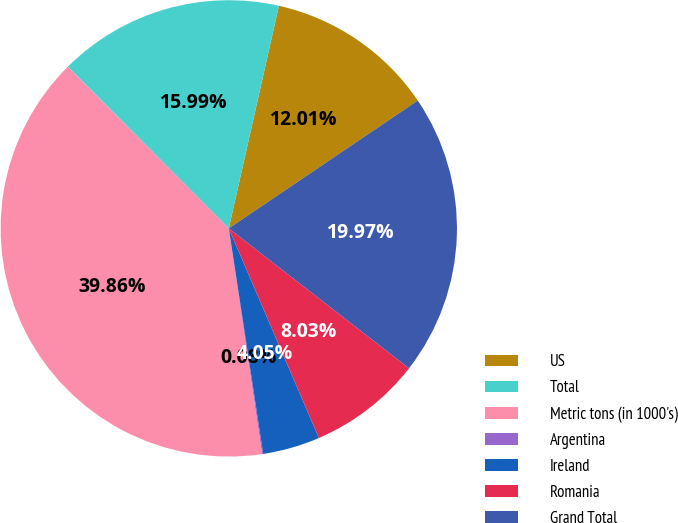Convert chart. <chart><loc_0><loc_0><loc_500><loc_500><pie_chart><fcel>US<fcel>Total<fcel>Metric tons (in 1000's)<fcel>Argentina<fcel>Ireland<fcel>Romania<fcel>Grand Total<nl><fcel>12.01%<fcel>15.99%<fcel>39.86%<fcel>0.08%<fcel>4.05%<fcel>8.03%<fcel>19.97%<nl></chart> 